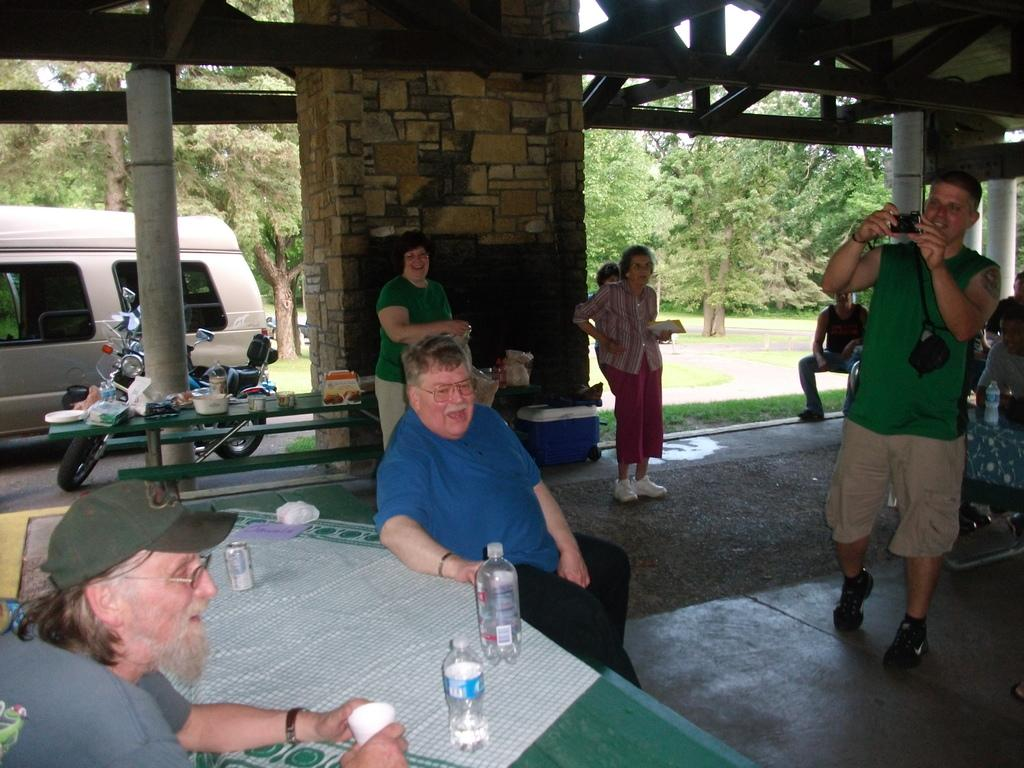How many people are in the image? There are people in the image, but the exact number cannot be determined from the provided facts. What is the main object in the image? There is a table in the image. What else can be seen on the table? Bottles are visible on the table in the image. What type of vehicles are in the image? There are vehicles in the image, but the specific type cannot be determined from the provided facts. What is the background of the image? There is a wall in the image, and trees are visible in the background. What type of furniture is being used for muscle training in the image? There is no furniture or muscle training present in the image. What book is the person reading in the image? There is no person reading a book in the image. 